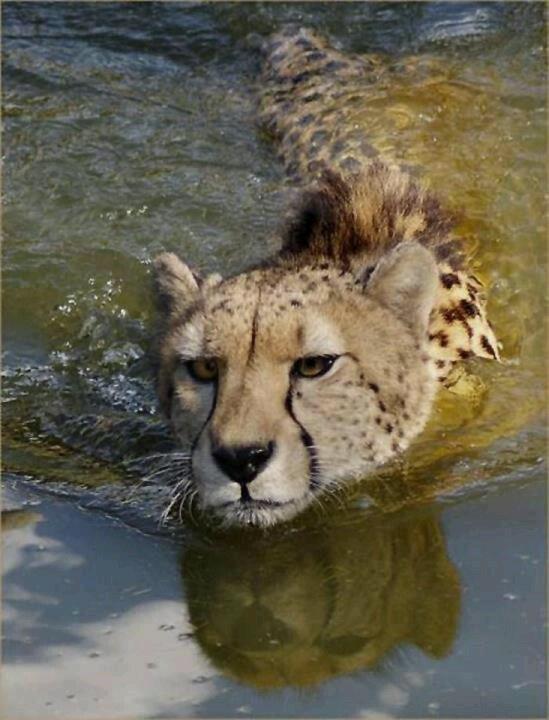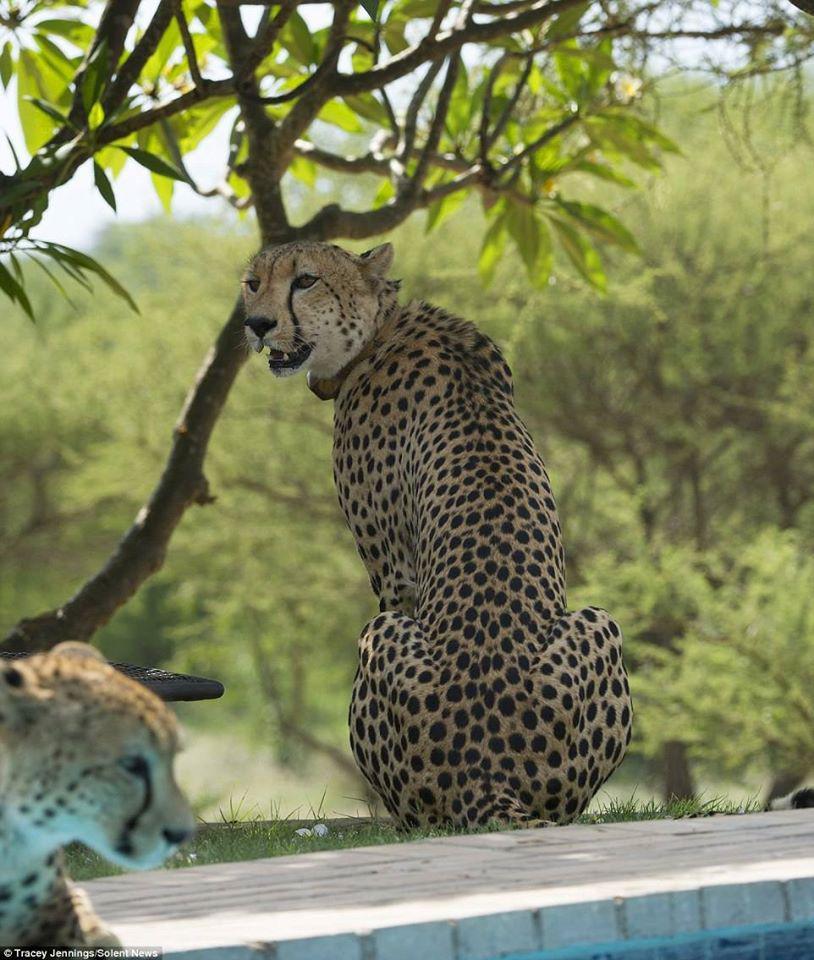The first image is the image on the left, the second image is the image on the right. Evaluate the accuracy of this statement regarding the images: "The left image contains one cheetah standing on the bank of a lake drinking water.". Is it true? Answer yes or no. No. The first image is the image on the left, the second image is the image on the right. Considering the images on both sides, is "Each image features one spotted wildcat and a body of water, and in one image, the cat is actually drinking at the edge of the water." valid? Answer yes or no. No. 